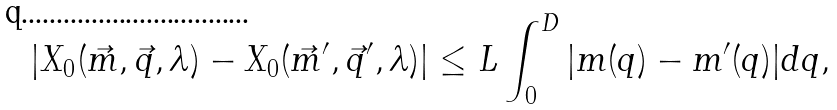Convert formula to latex. <formula><loc_0><loc_0><loc_500><loc_500>| X _ { 0 } ( \vec { m } , \vec { q } , \lambda ) - X _ { 0 } ( \vec { m } ^ { \prime } , \vec { q } ^ { \prime } , \lambda ) | \leq L \int _ { 0 } ^ { D } | m ( q ) - m ^ { \prime } ( q ) | d q ,</formula> 